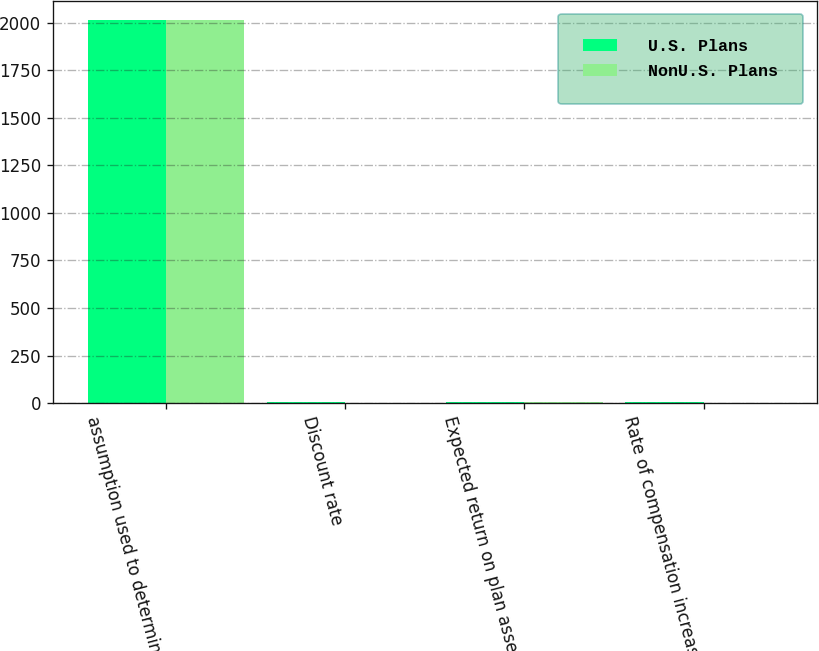<chart> <loc_0><loc_0><loc_500><loc_500><stacked_bar_chart><ecel><fcel>assumption used to determine<fcel>Discount rate<fcel>Expected return on plan assets<fcel>Rate of compensation increase<nl><fcel>U.S. Plans<fcel>2015<fcel>3.9<fcel>7.3<fcel>3.25<nl><fcel>NonU.S. Plans<fcel>2015<fcel>2.74<fcel>6.24<fcel>2<nl></chart> 